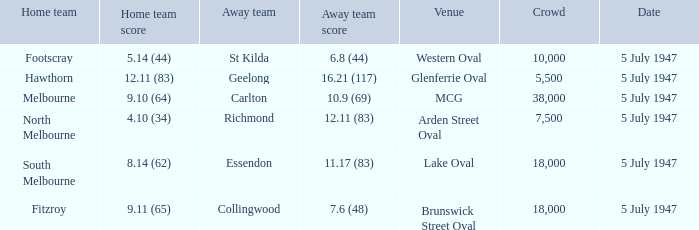Where was the game played where the away team has a score of 7.6 (48)? Brunswick Street Oval. 